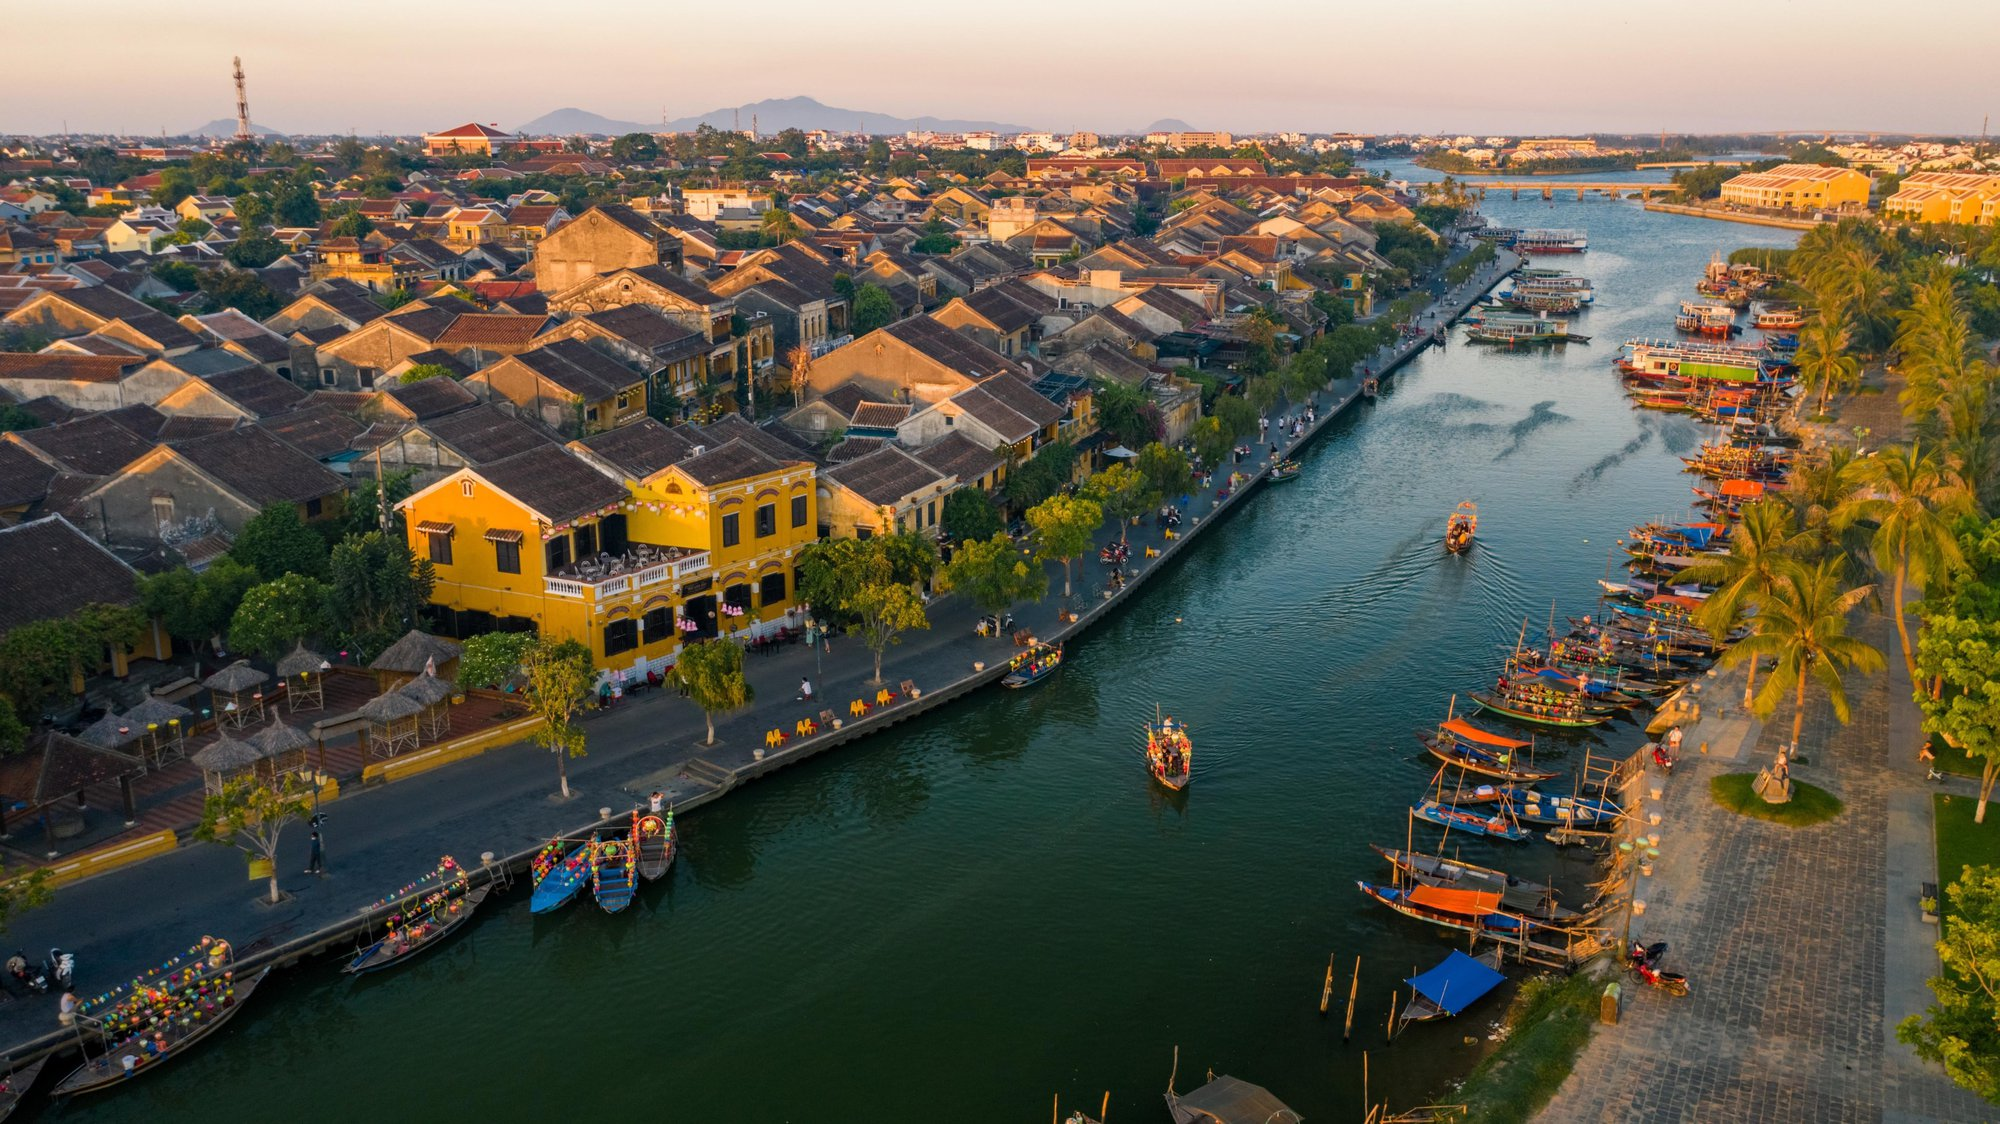Describe the types of boats visible in the image and their possible uses in daily life. The image showcases several traditional wooden boats, each vividly adorned with arrays of colored lanterns, which suggests their use in tourism for river cruises. These boats, with their flat bottoms and wide hulls, are ideal for navigating the shallow waters of the Thu Bon River. They likely serve both functional and ceremonial purposes, such as ferrying locals and tourists alike and being central to festivals and community gatherings. 